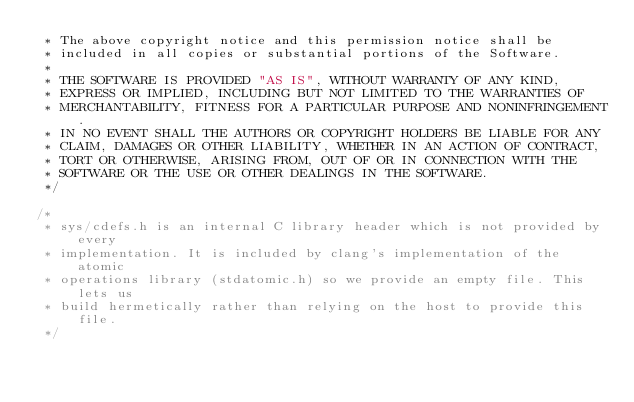Convert code to text. <code><loc_0><loc_0><loc_500><loc_500><_C_> * The above copyright notice and this permission notice shall be
 * included in all copies or substantial portions of the Software.
 *
 * THE SOFTWARE IS PROVIDED "AS IS", WITHOUT WARRANTY OF ANY KIND,
 * EXPRESS OR IMPLIED, INCLUDING BUT NOT LIMITED TO THE WARRANTIES OF
 * MERCHANTABILITY, FITNESS FOR A PARTICULAR PURPOSE AND NONINFRINGEMENT.
 * IN NO EVENT SHALL THE AUTHORS OR COPYRIGHT HOLDERS BE LIABLE FOR ANY
 * CLAIM, DAMAGES OR OTHER LIABILITY, WHETHER IN AN ACTION OF CONTRACT,
 * TORT OR OTHERWISE, ARISING FROM, OUT OF OR IN CONNECTION WITH THE
 * SOFTWARE OR THE USE OR OTHER DEALINGS IN THE SOFTWARE.
 */

/*
 * sys/cdefs.h is an internal C library header which is not provided by every
 * implementation. It is included by clang's implementation of the atomic
 * operations library (stdatomic.h) so we provide an empty file. This lets us
 * build hermetically rather than relying on the host to provide this file.
 */
</code> 